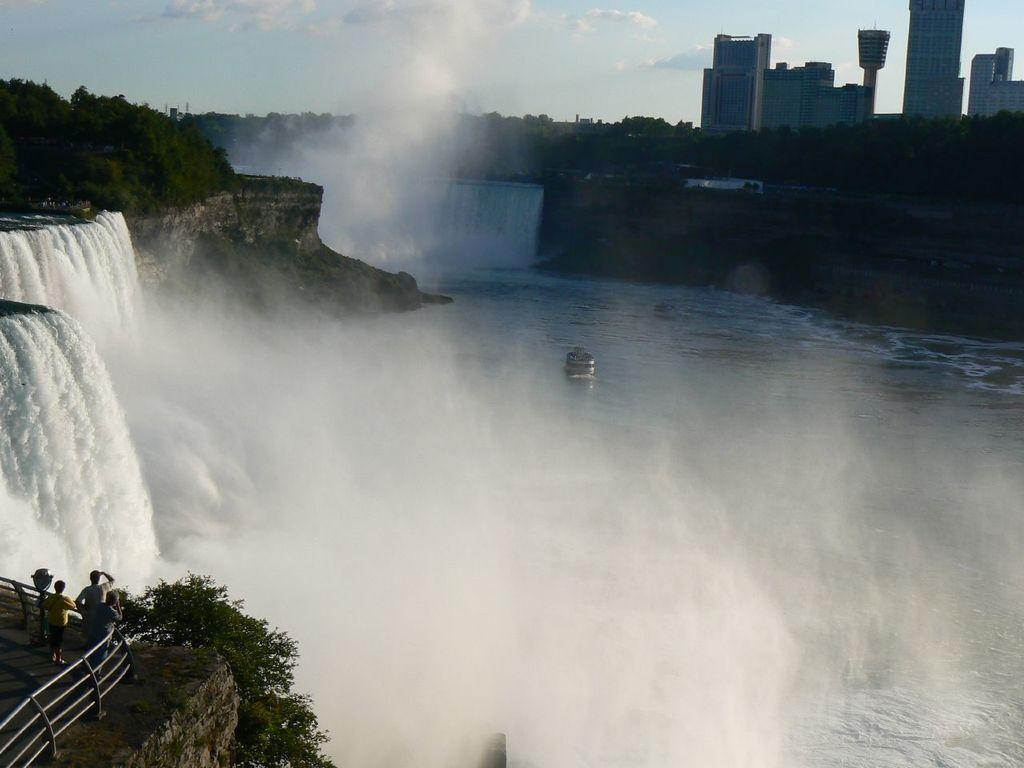Could you give a brief overview of what you see in this image? In this picture we can see the waterfalls. On the left side of the image there are iron grilles, trees and people. At the top right corner of the image, there are buildings and the sky. 